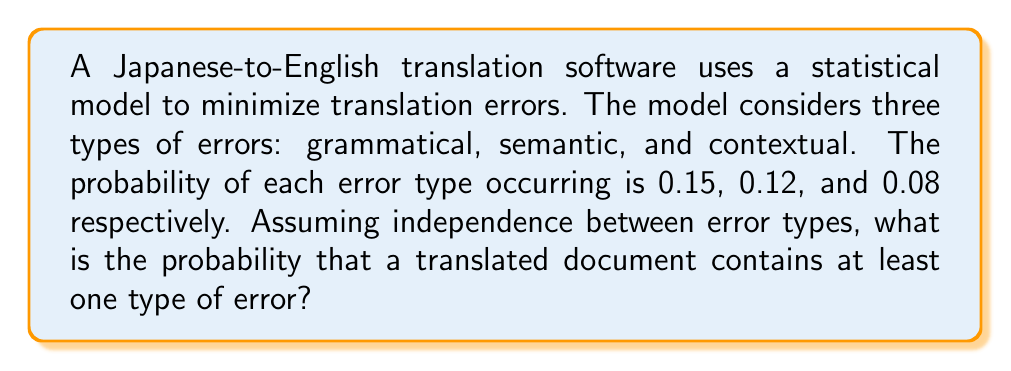Can you answer this question? To solve this problem, we'll use the concept of probability of complementary events. Let's follow these steps:

1) First, let's define our events:
   G: Grammatical error occurs
   S: Semantic error occurs
   C: Contextual error occurs

2) We're given the following probabilities:
   P(G) = 0.15
   P(S) = 0.12
   P(C) = 0.08

3) We want to find the probability of at least one type of error occurring. This is equivalent to 1 minus the probability of no errors occurring.

4) The probability of no grammatical error is:
   P(not G) = 1 - P(G) = 1 - 0.15 = 0.85

5) Similarly:
   P(not S) = 1 - P(S) = 1 - 0.12 = 0.88
   P(not C) = 1 - P(C) = 1 - 0.08 = 0.92

6) Since we're assuming independence, the probability of no errors at all is the product of these probabilities:

   P(no errors) = P(not G) * P(not S) * P(not C)
                = 0.85 * 0.88 * 0.92
                = 0.6877

7) Therefore, the probability of at least one error is:

   P(at least one error) = 1 - P(no errors)
                         = 1 - 0.6877
                         = 0.3123

8) This can be rounded to 0.3123 or expressed as a percentage: 31.23%
Answer: The probability that a translated document contains at least one type of error is approximately 0.3123 or 31.23%. 